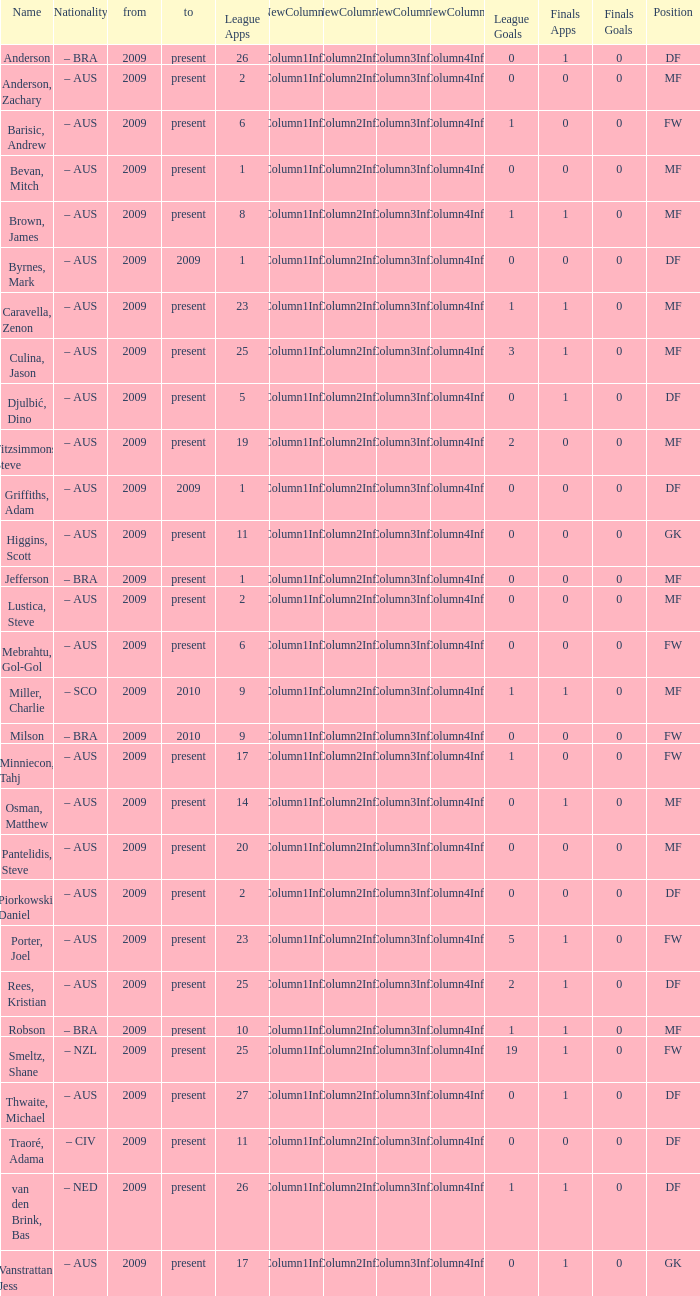Name the position for van den brink, bas DF. 